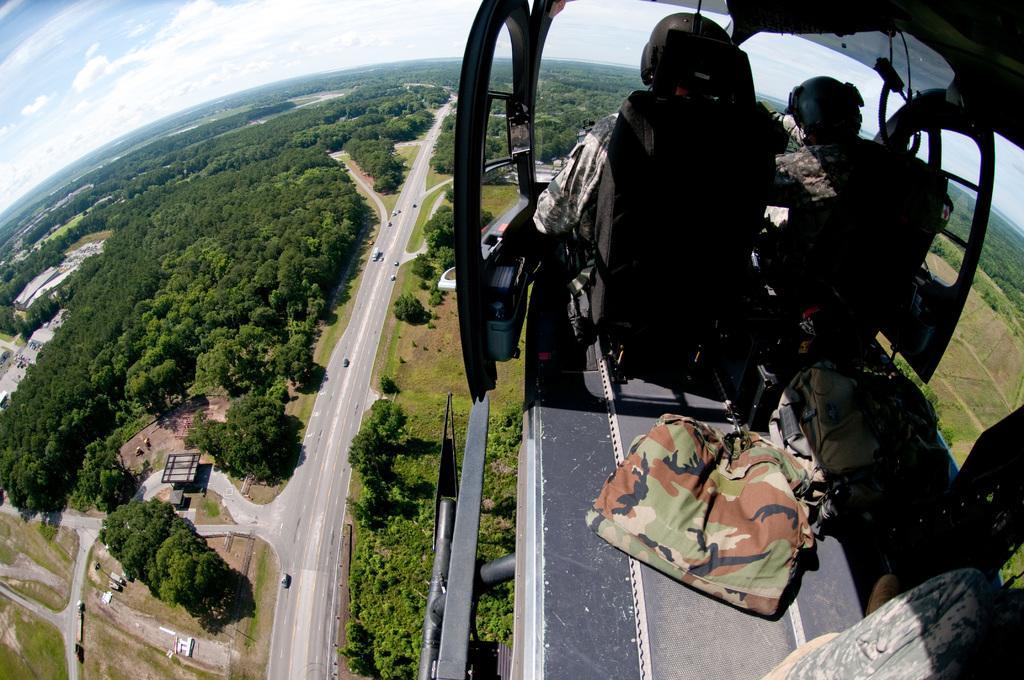Please provide a concise description of this image. In this image, we can see few people are riding a helicopter. Here we can see rods, bags and few objects. Background we can see roads, houses, vehicles, trees, plants and grass. Here we can see a cloudy sky. 